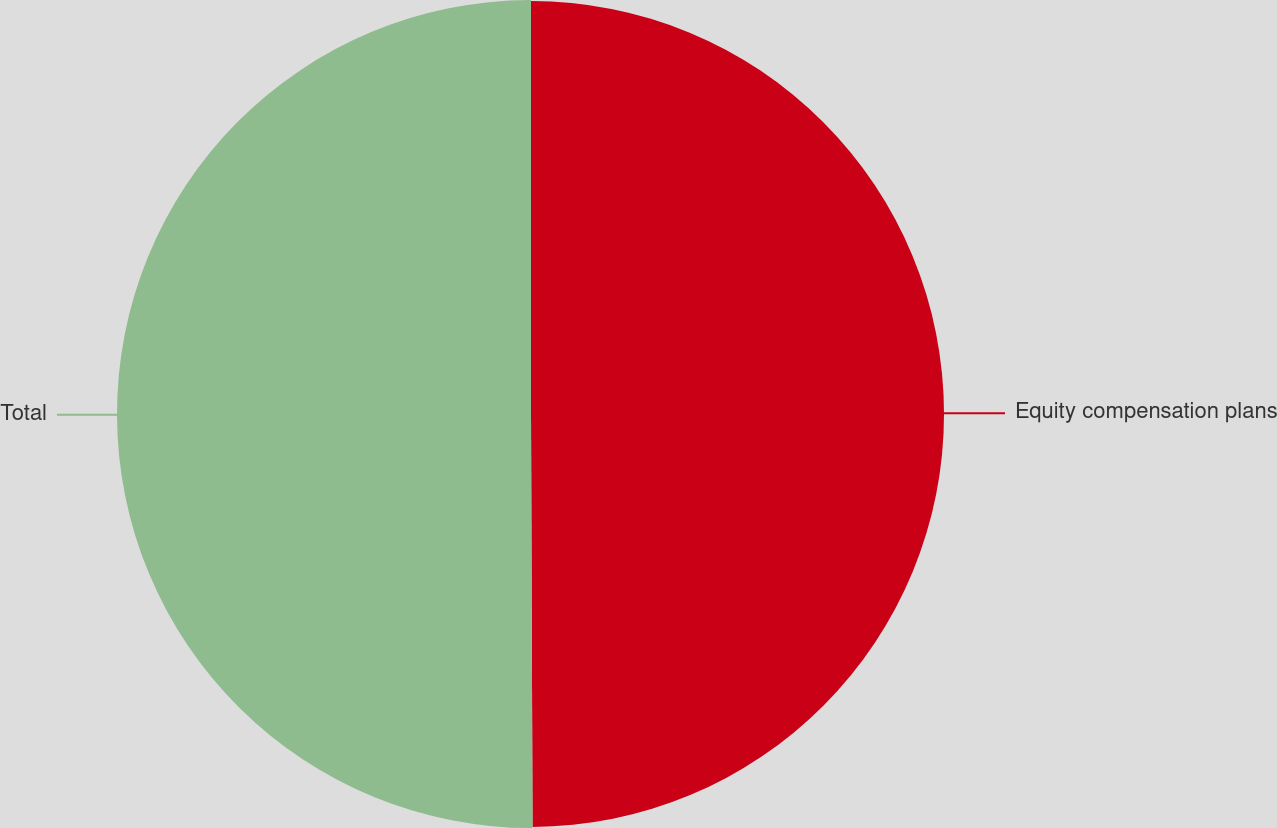Convert chart. <chart><loc_0><loc_0><loc_500><loc_500><pie_chart><fcel>Equity compensation plans<fcel>Total<nl><fcel>49.94%<fcel>50.06%<nl></chart> 